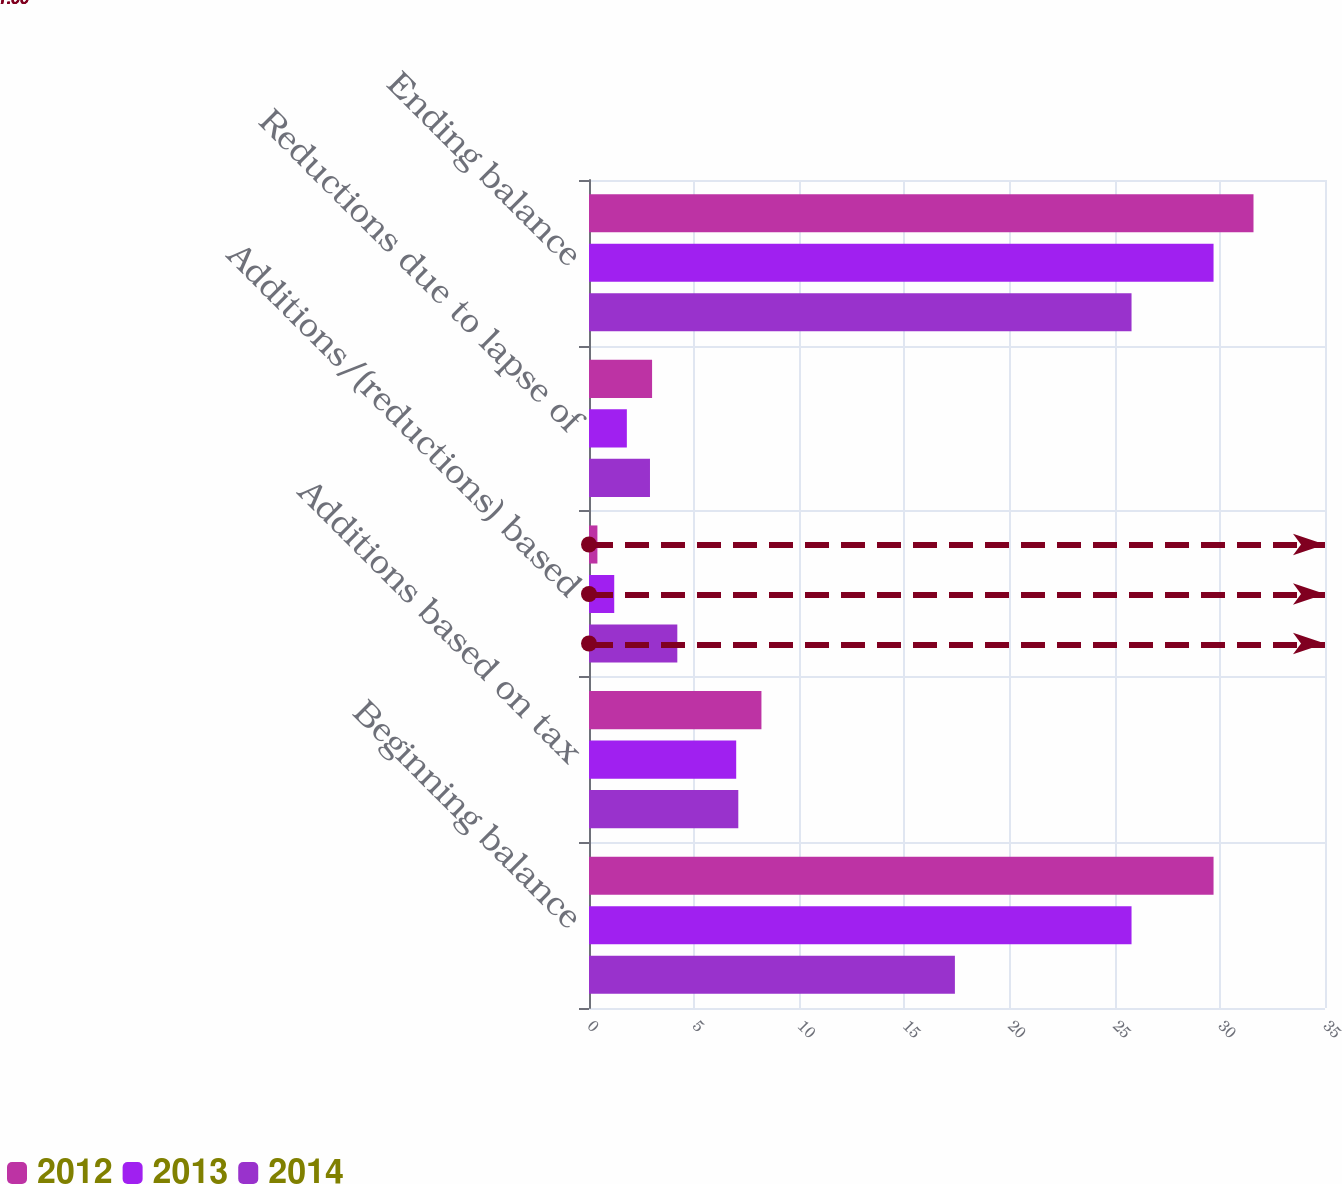<chart> <loc_0><loc_0><loc_500><loc_500><stacked_bar_chart><ecel><fcel>Beginning balance<fcel>Additions based on tax<fcel>Additions/(reductions) based<fcel>Reductions due to lapse of<fcel>Ending balance<nl><fcel>2012<fcel>29.7<fcel>8.2<fcel>0.4<fcel>3<fcel>31.6<nl><fcel>2013<fcel>25.8<fcel>7<fcel>1.2<fcel>1.8<fcel>29.7<nl><fcel>2014<fcel>17.4<fcel>7.1<fcel>4.2<fcel>2.9<fcel>25.8<nl></chart> 